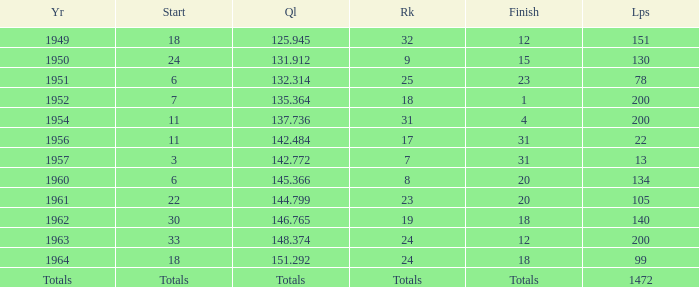Name the year for laps of 200 and rank of 24 1963.0. 